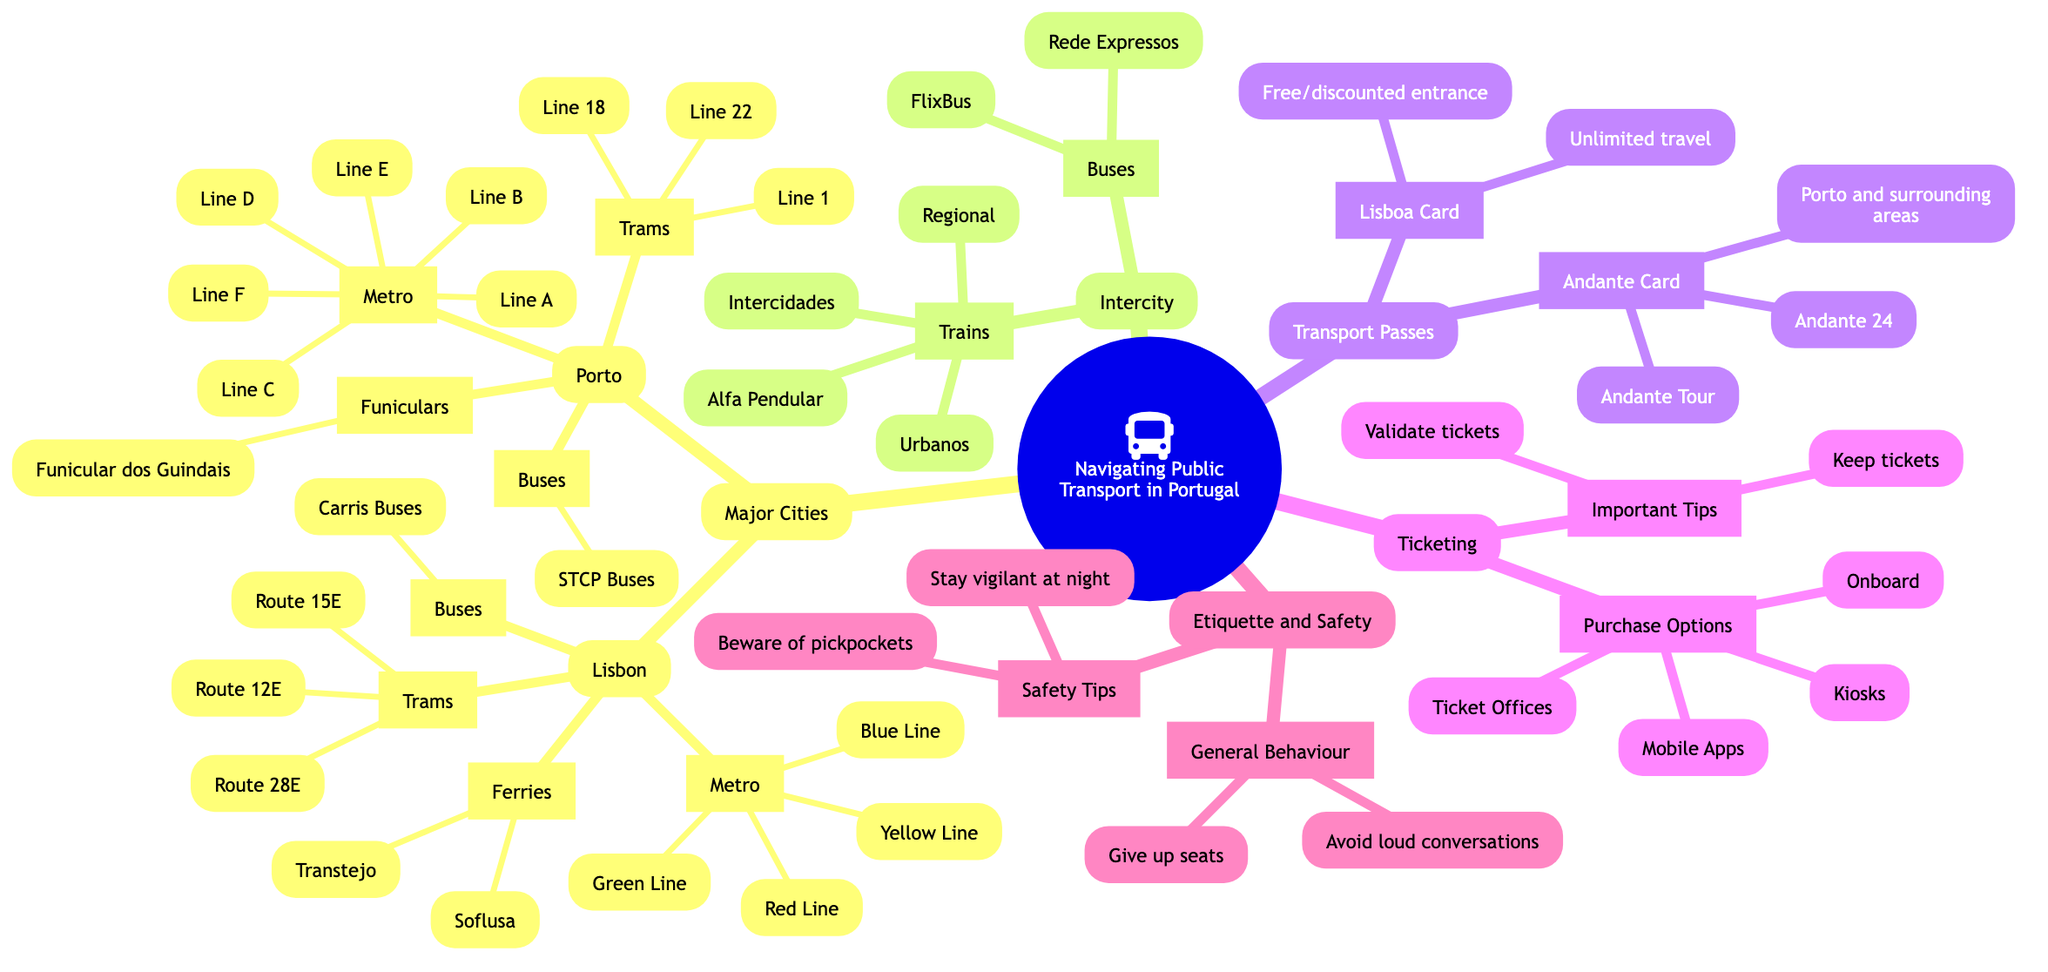What are the tram routes available in Lisbon? In the diagram under the "Lisbon" node, the "Trams" subnode lists the available routes. The routes mentioned are Route 28E, Route 12E, and Route 15E.
Answer: Route 28E, Route 12E, Route 15E How many metro lines are there in Porto? The "Porto" node under "Major Cities" contains a "Metro" subnode that lists various lines. There are six metro lines listed: Line A, Line B, Line C, Line D, Line E, Line F. Counting these lines gives us a total of six.
Answer: 6 What type of safety tips are recommended for public transport? Under the "Etiquette and Safety" section, the "Safety Tips" subnode mentions specific advice regarding safety. It includes "Beware of pickpockets" and "Stay vigilant at night." Therefore, the safety tips are listed in this context.
Answer: Beware of pickpockets, Stay vigilant at night How do you purchase tickets for public transport? The "Ticketing" section indicates various "Ticket Purchase" options. The methods listed include Kiosks, Mobile Apps, Ticket Offices, and Onboard. This provides a clear overview of the available purchasing methods.
Answer: Kiosks, Mobile Apps, Ticket Offices, Onboard What are the features of the Lisboa Card? Under "Transport Passes," the "Lisboa Card" subnode outlines its features. It states "Unlimited travel on public transport" and "Free or discounted entrance to attractions," indicating the benefits of using this pass.
Answer: Unlimited travel on public transport, Free or discounted entrance to attractions Which buses operate intercity transport? The "Intercity" portion of the mind map states that intercity transport can be traversed using buses specifically mentioned. The bus types listed are Rede Expressos and FlixBus, which are designed for intercity travel.
Answer: Rede Expressos, FlixBus What is the behavior expected in public transport regarding seating? Under the "Etiquette and Safety" section, the "General Behaviour" subnode highlights expected conduct in terms of seating. One article states "Give up seats for elderly or pregnant passengers," which implies an accepted social norm in the context of public transport.
Answer: Give up seats for elderly or pregnant passengers How many different types of trains are mentioned for intercity travel? The "Intercity" section lists four types of trains available. These are Alfa Pendular, Intercidades, Regional, and Urbanos, which totals to four options for intercity train travel as described in the diagram.
Answer: 4 